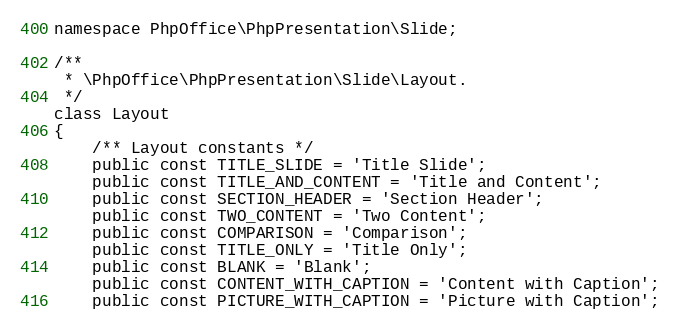<code> <loc_0><loc_0><loc_500><loc_500><_PHP_>namespace PhpOffice\PhpPresentation\Slide;

/**
 * \PhpOffice\PhpPresentation\Slide\Layout.
 */
class Layout
{
    /** Layout constants */
    public const TITLE_SLIDE = 'Title Slide';
    public const TITLE_AND_CONTENT = 'Title and Content';
    public const SECTION_HEADER = 'Section Header';
    public const TWO_CONTENT = 'Two Content';
    public const COMPARISON = 'Comparison';
    public const TITLE_ONLY = 'Title Only';
    public const BLANK = 'Blank';
    public const CONTENT_WITH_CAPTION = 'Content with Caption';
    public const PICTURE_WITH_CAPTION = 'Picture with Caption';</code> 